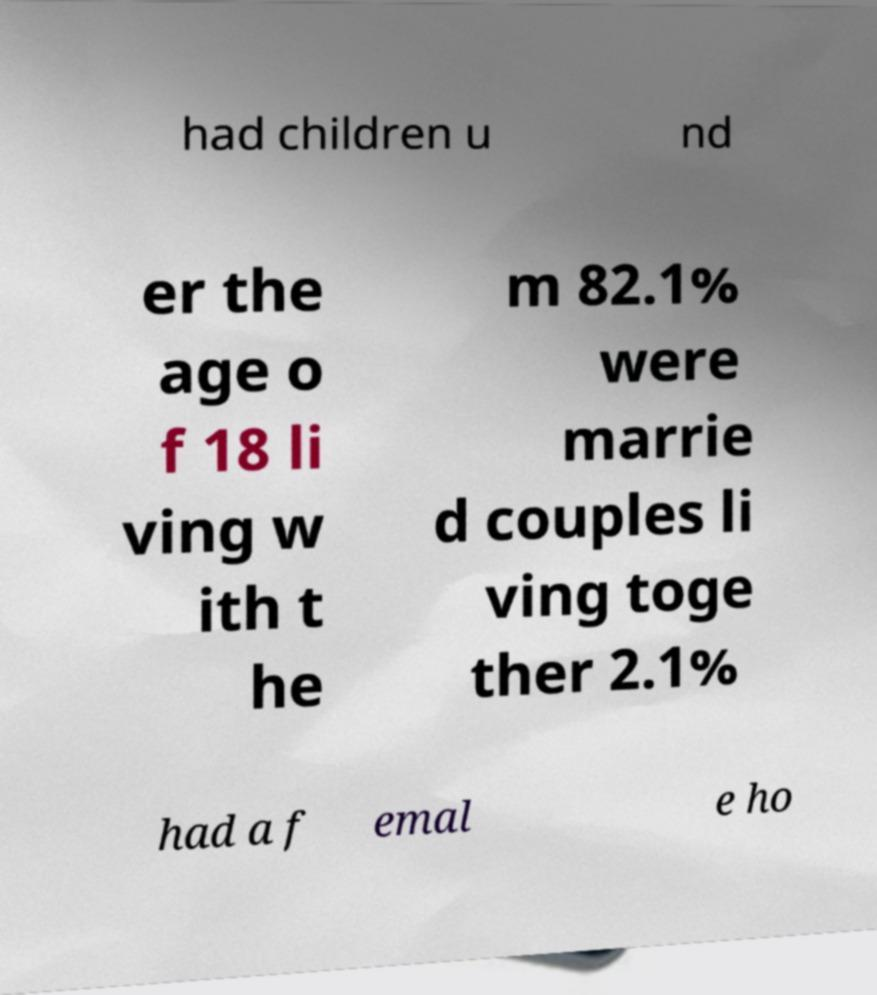What messages or text are displayed in this image? I need them in a readable, typed format. had children u nd er the age o f 18 li ving w ith t he m 82.1% were marrie d couples li ving toge ther 2.1% had a f emal e ho 